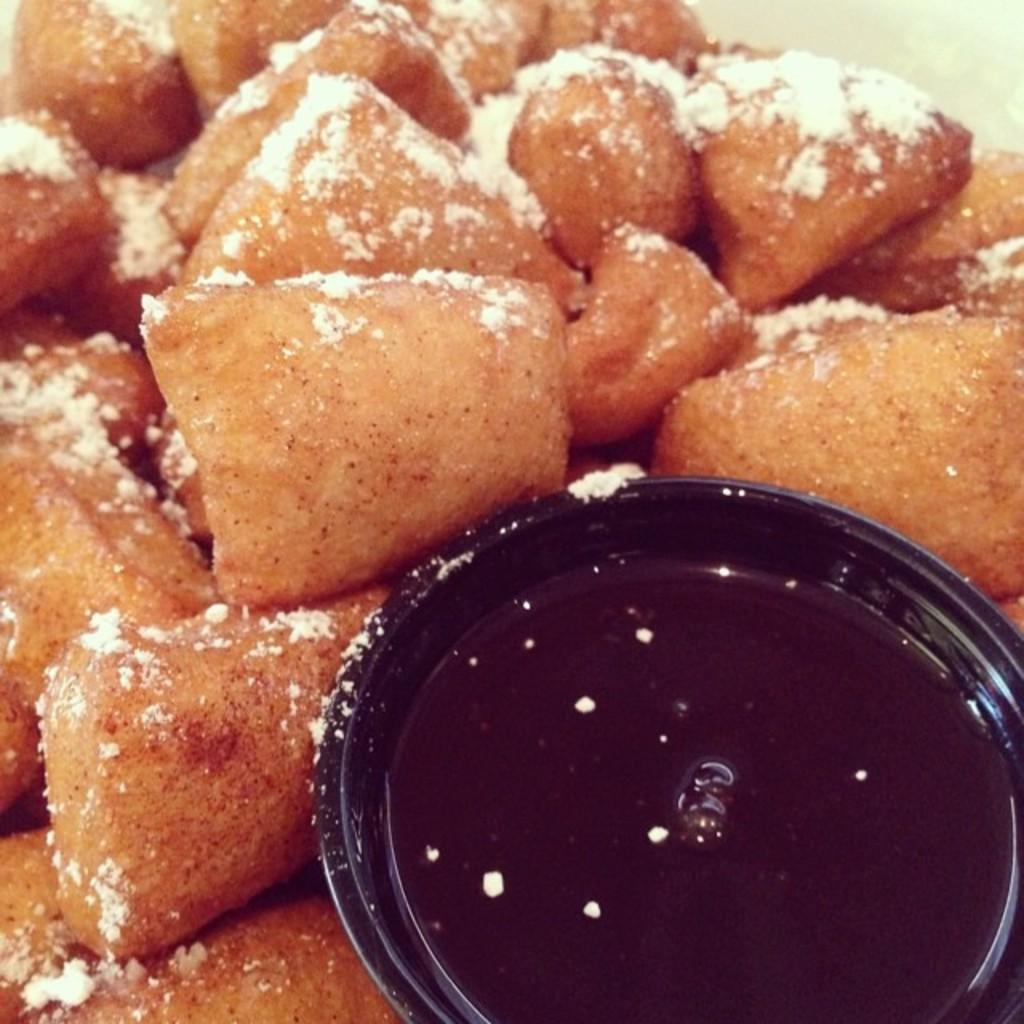What can be seen in the image related to food? There is food in the image. What type of container is present in the image? There is a bowl in the image. How many sheep are visible in the image? There are no sheep present in the image. What type of material is the dirt made of in the image? There is no dirt present in the image. 